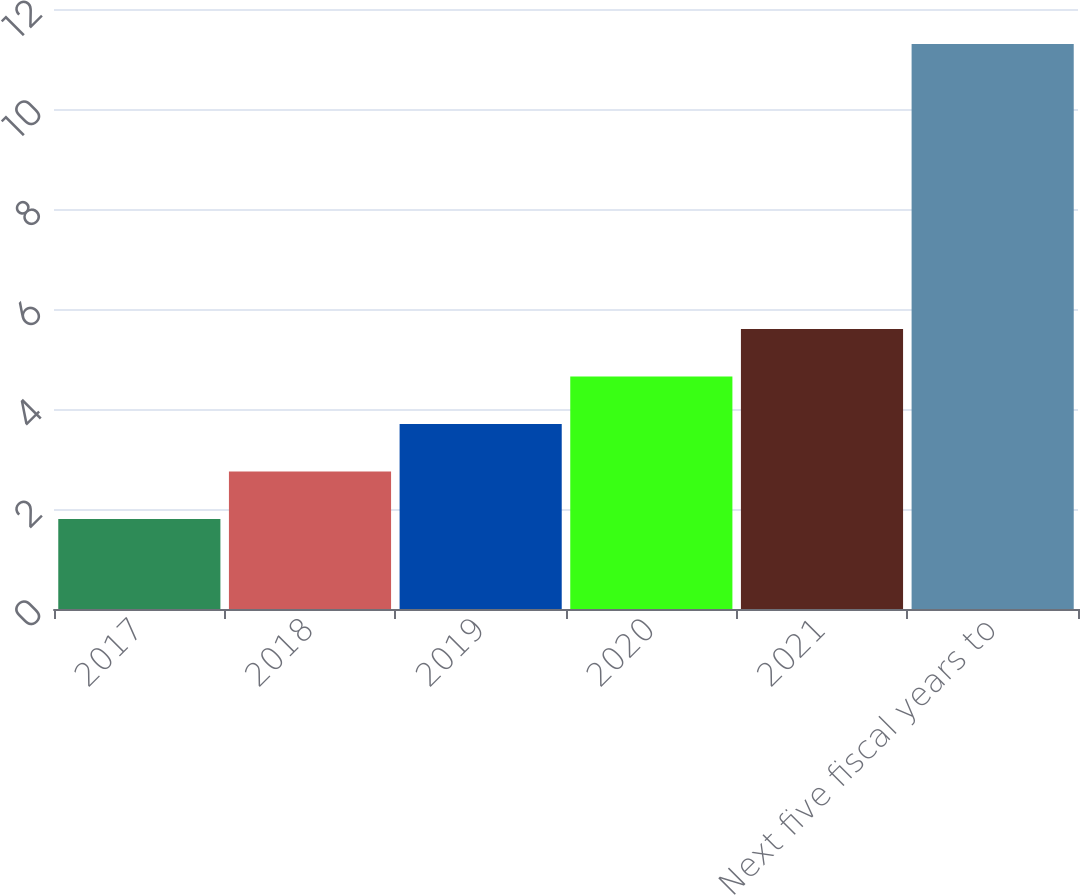Convert chart to OTSL. <chart><loc_0><loc_0><loc_500><loc_500><bar_chart><fcel>2017<fcel>2018<fcel>2019<fcel>2020<fcel>2021<fcel>Next five fiscal years to<nl><fcel>1.8<fcel>2.75<fcel>3.7<fcel>4.65<fcel>5.6<fcel>11.3<nl></chart> 